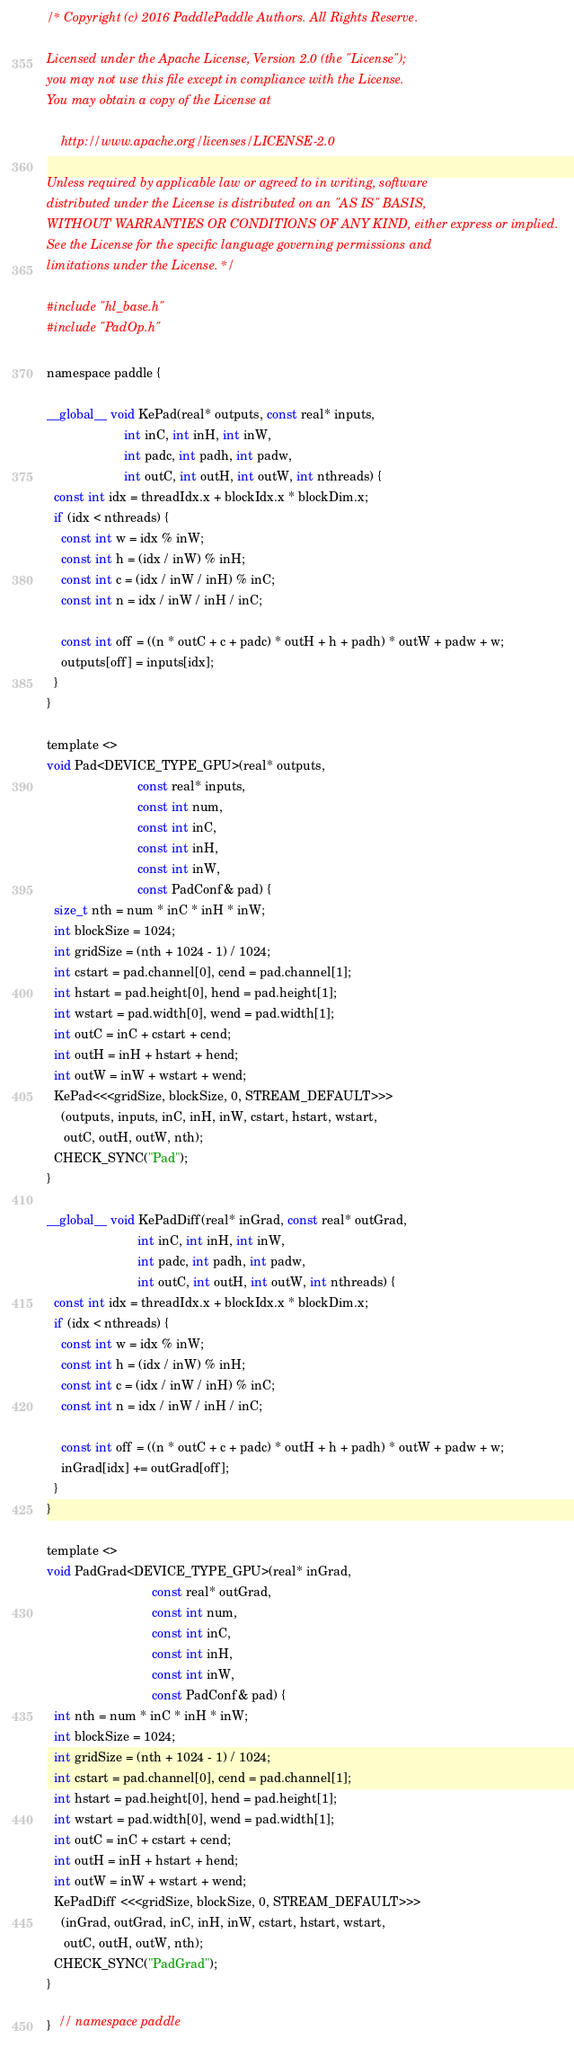Convert code to text. <code><loc_0><loc_0><loc_500><loc_500><_Cuda_>/* Copyright (c) 2016 PaddlePaddle Authors. All Rights Reserve.

Licensed under the Apache License, Version 2.0 (the "License");
you may not use this file except in compliance with the License.
You may obtain a copy of the License at

    http://www.apache.org/licenses/LICENSE-2.0

Unless required by applicable law or agreed to in writing, software
distributed under the License is distributed on an "AS IS" BASIS,
WITHOUT WARRANTIES OR CONDITIONS OF ANY KIND, either express or implied.
See the License for the specific language governing permissions and
limitations under the License. */

#include "hl_base.h"
#include "PadOp.h"

namespace paddle {

__global__ void KePad(real* outputs, const real* inputs,
                      int inC, int inH, int inW,
                      int padc, int padh, int padw,
                      int outC, int outH, int outW, int nthreads) {
  const int idx = threadIdx.x + blockIdx.x * blockDim.x;
  if (idx < nthreads) {
    const int w = idx % inW;
    const int h = (idx / inW) % inH;
    const int c = (idx / inW / inH) % inC;
    const int n = idx / inW / inH / inC;

    const int off = ((n * outC + c + padc) * outH + h + padh) * outW + padw + w;
    outputs[off] = inputs[idx];
  }
}

template <>
void Pad<DEVICE_TYPE_GPU>(real* outputs,
                          const real* inputs,
                          const int num,
                          const int inC,
                          const int inH,
                          const int inW,
                          const PadConf& pad) {
  size_t nth = num * inC * inH * inW;
  int blockSize = 1024;
  int gridSize = (nth + 1024 - 1) / 1024;
  int cstart = pad.channel[0], cend = pad.channel[1];
  int hstart = pad.height[0], hend = pad.height[1];
  int wstart = pad.width[0], wend = pad.width[1];
  int outC = inC + cstart + cend;
  int outH = inH + hstart + hend;
  int outW = inW + wstart + wend;
  KePad<<<gridSize, blockSize, 0, STREAM_DEFAULT>>>
    (outputs, inputs, inC, inH, inW, cstart, hstart, wstart,
     outC, outH, outW, nth);
  CHECK_SYNC("Pad");
}

__global__ void KePadDiff(real* inGrad, const real* outGrad,
                          int inC, int inH, int inW,
                          int padc, int padh, int padw,
                          int outC, int outH, int outW, int nthreads) {
  const int idx = threadIdx.x + blockIdx.x * blockDim.x;
  if (idx < nthreads) {
    const int w = idx % inW;
    const int h = (idx / inW) % inH;
    const int c = (idx / inW / inH) % inC;
    const int n = idx / inW / inH / inC;

    const int off = ((n * outC + c + padc) * outH + h + padh) * outW + padw + w;
    inGrad[idx] += outGrad[off];
  }
}

template <>
void PadGrad<DEVICE_TYPE_GPU>(real* inGrad,
                              const real* outGrad,
                              const int num,
                              const int inC,
                              const int inH,
                              const int inW,
                              const PadConf& pad) {
  int nth = num * inC * inH * inW;
  int blockSize = 1024;
  int gridSize = (nth + 1024 - 1) / 1024;
  int cstart = pad.channel[0], cend = pad.channel[1];
  int hstart = pad.height[0], hend = pad.height[1];
  int wstart = pad.width[0], wend = pad.width[1];
  int outC = inC + cstart + cend;
  int outH = inH + hstart + hend;
  int outW = inW + wstart + wend;
  KePadDiff <<<gridSize, blockSize, 0, STREAM_DEFAULT>>>
    (inGrad, outGrad, inC, inH, inW, cstart, hstart, wstart,
     outC, outH, outW, nth);
  CHECK_SYNC("PadGrad");
}

}  // namespace paddle
</code> 